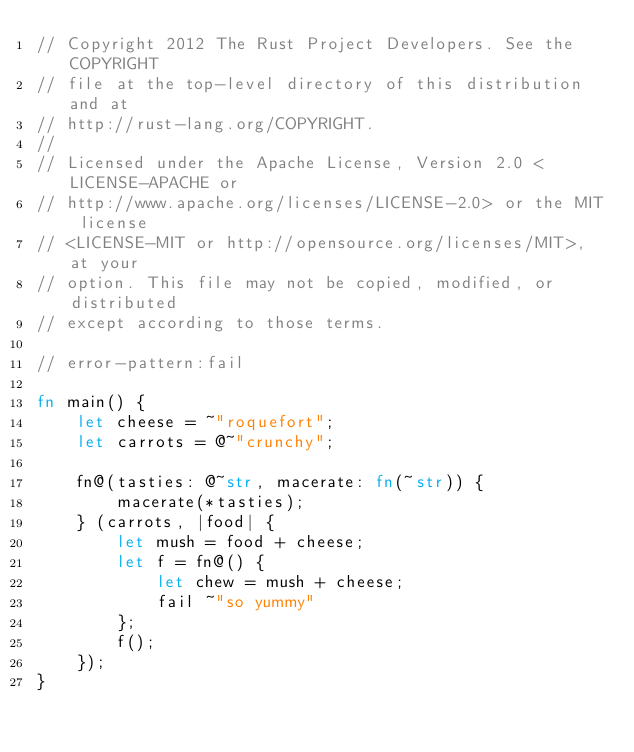<code> <loc_0><loc_0><loc_500><loc_500><_Rust_>// Copyright 2012 The Rust Project Developers. See the COPYRIGHT
// file at the top-level directory of this distribution and at
// http://rust-lang.org/COPYRIGHT.
//
// Licensed under the Apache License, Version 2.0 <LICENSE-APACHE or
// http://www.apache.org/licenses/LICENSE-2.0> or the MIT license
// <LICENSE-MIT or http://opensource.org/licenses/MIT>, at your
// option. This file may not be copied, modified, or distributed
// except according to those terms.

// error-pattern:fail

fn main() {
    let cheese = ~"roquefort";
    let carrots = @~"crunchy";

    fn@(tasties: @~str, macerate: fn(~str)) {
        macerate(*tasties);
    } (carrots, |food| {
        let mush = food + cheese;
        let f = fn@() {
            let chew = mush + cheese;
            fail ~"so yummy"
        };
        f();
    });
}</code> 